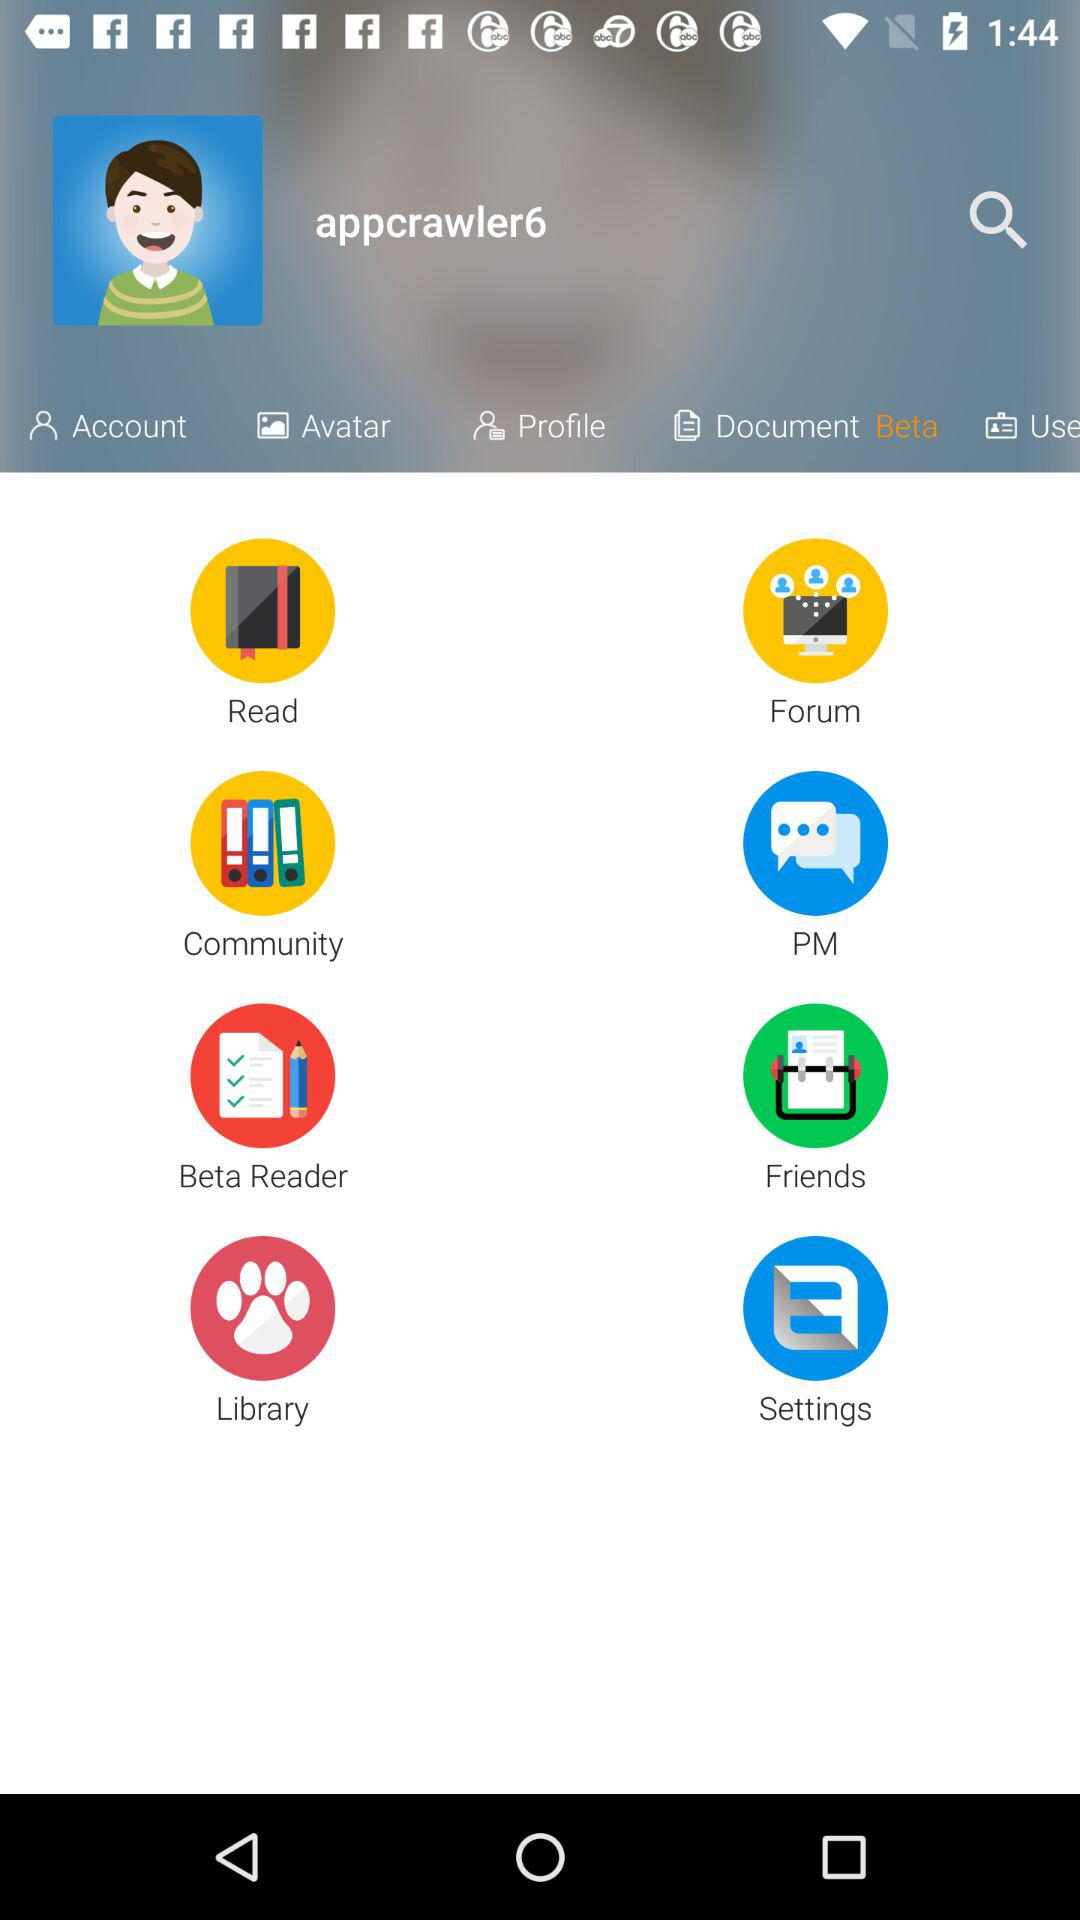What is the name of the user? The name of the user is appcrawler6. 